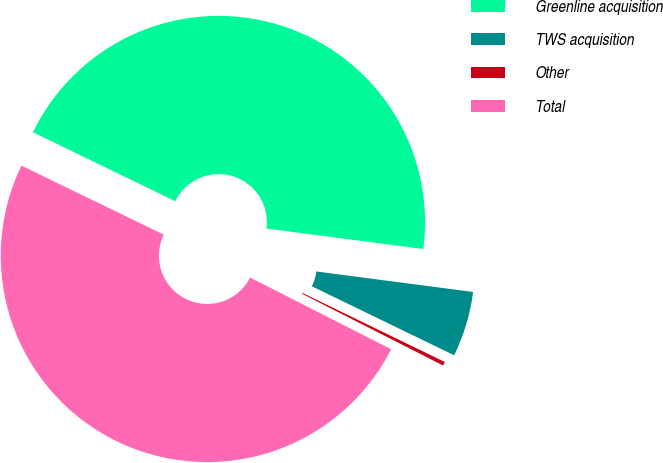<chart> <loc_0><loc_0><loc_500><loc_500><pie_chart><fcel>Greenline acquisition<fcel>TWS acquisition<fcel>Other<fcel>Total<nl><fcel>44.88%<fcel>5.12%<fcel>0.3%<fcel>49.7%<nl></chart> 